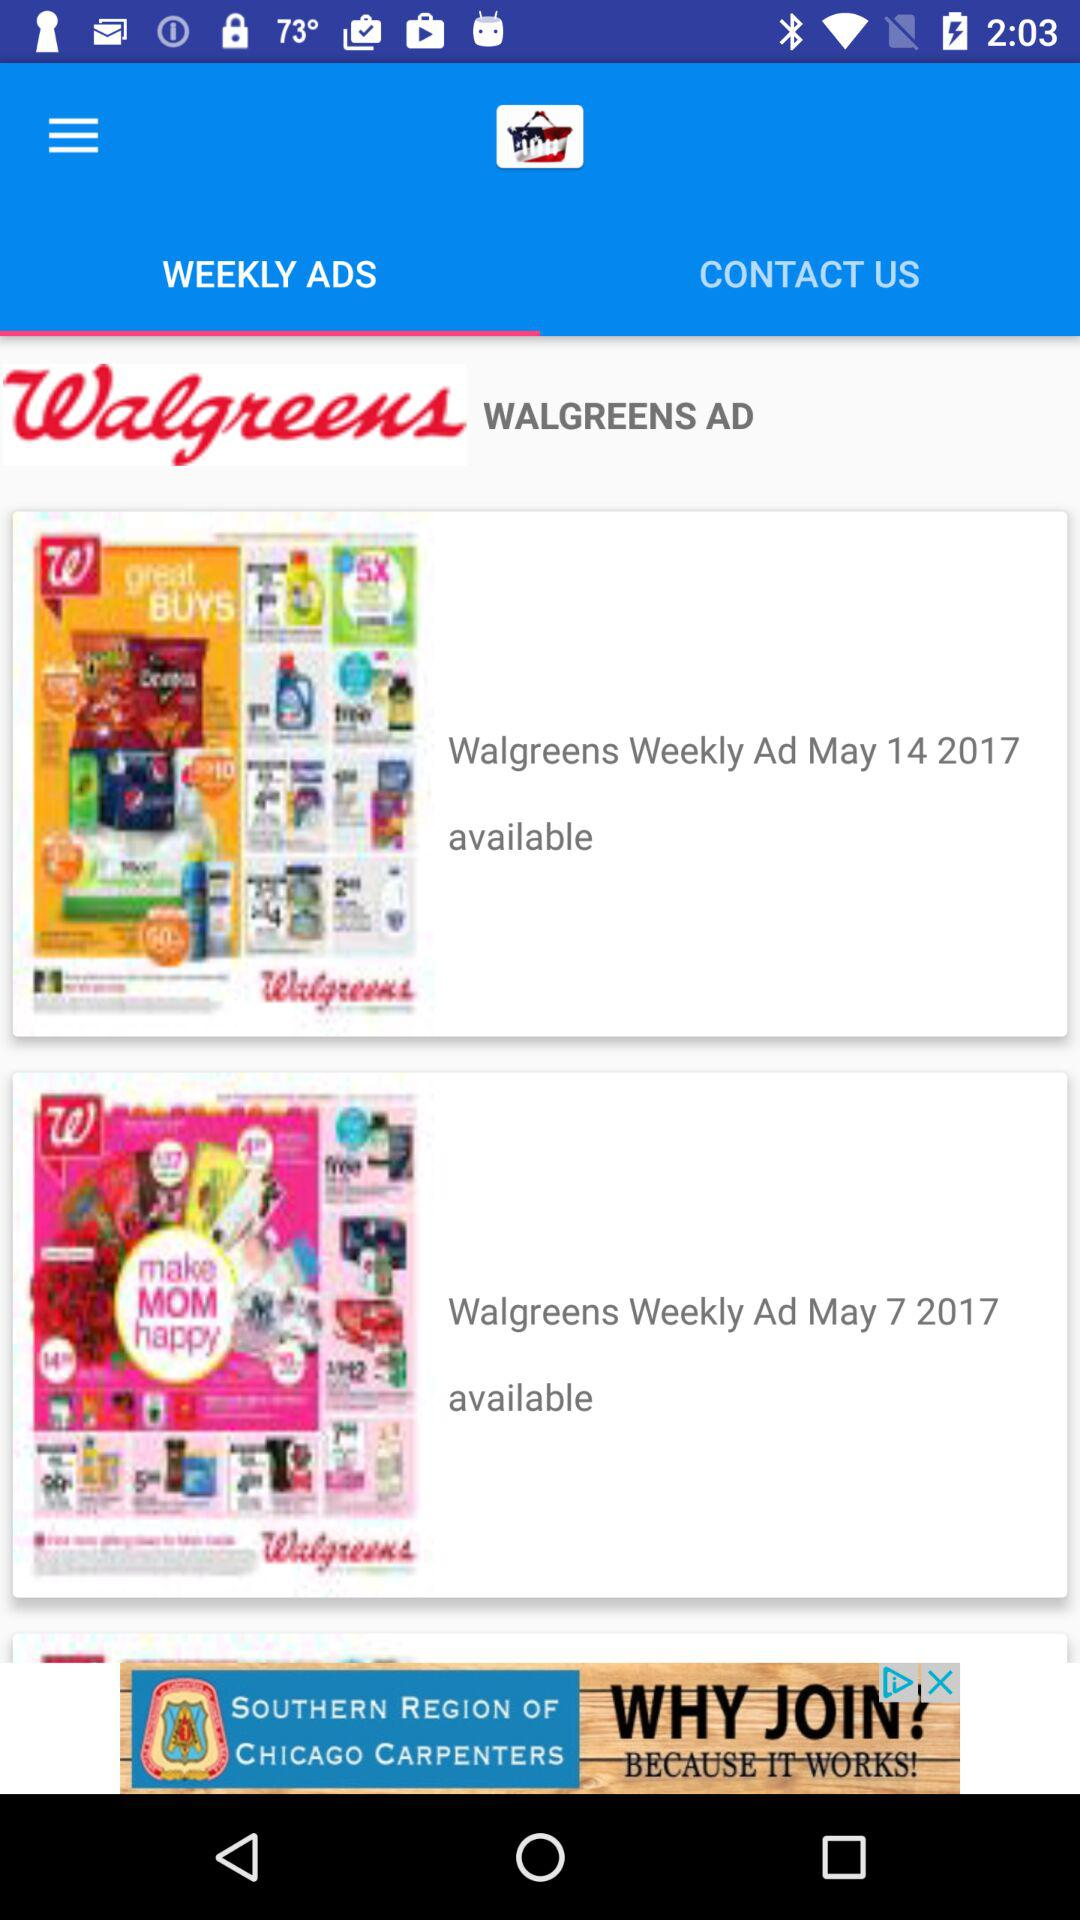What is the status of "Walgreens Weekly Ad May 7 2017"? The status is "available". 